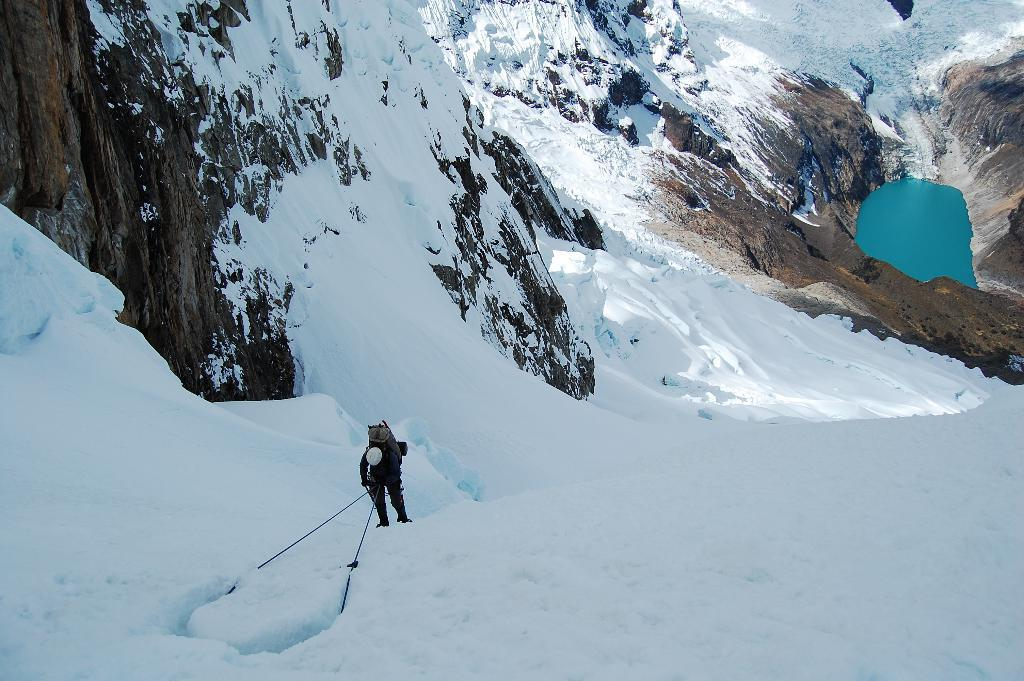What is the man in the image doing? The man is climbing a mountain in the image. What is the terrain like in the area? The area is covered with snow. How many mountains can be seen in the image? There are mountains visible in the image. What natural feature is present in the valley? There is a small pond in the valley. What type of growth can be seen on the train tracks in the image? There are no train tracks or growth present in the image. 